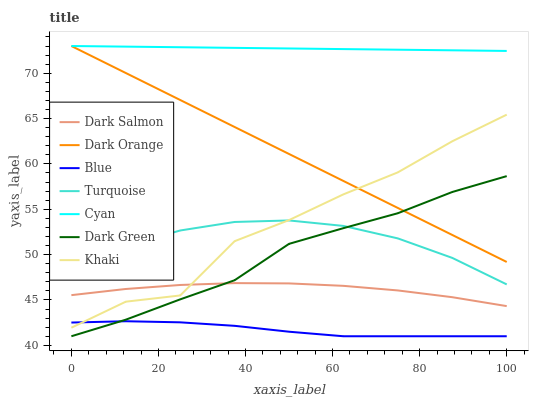Does Blue have the minimum area under the curve?
Answer yes or no. Yes. Does Cyan have the maximum area under the curve?
Answer yes or no. Yes. Does Dark Orange have the minimum area under the curve?
Answer yes or no. No. Does Dark Orange have the maximum area under the curve?
Answer yes or no. No. Is Cyan the smoothest?
Answer yes or no. Yes. Is Khaki the roughest?
Answer yes or no. Yes. Is Dark Orange the smoothest?
Answer yes or no. No. Is Dark Orange the roughest?
Answer yes or no. No. Does Dark Orange have the lowest value?
Answer yes or no. No. Does Cyan have the highest value?
Answer yes or no. Yes. Does Turquoise have the highest value?
Answer yes or no. No. Is Blue less than Turquoise?
Answer yes or no. Yes. Is Cyan greater than Khaki?
Answer yes or no. Yes. Does Dark Salmon intersect Dark Green?
Answer yes or no. Yes. Is Dark Salmon less than Dark Green?
Answer yes or no. No. Is Dark Salmon greater than Dark Green?
Answer yes or no. No. Does Blue intersect Turquoise?
Answer yes or no. No. 